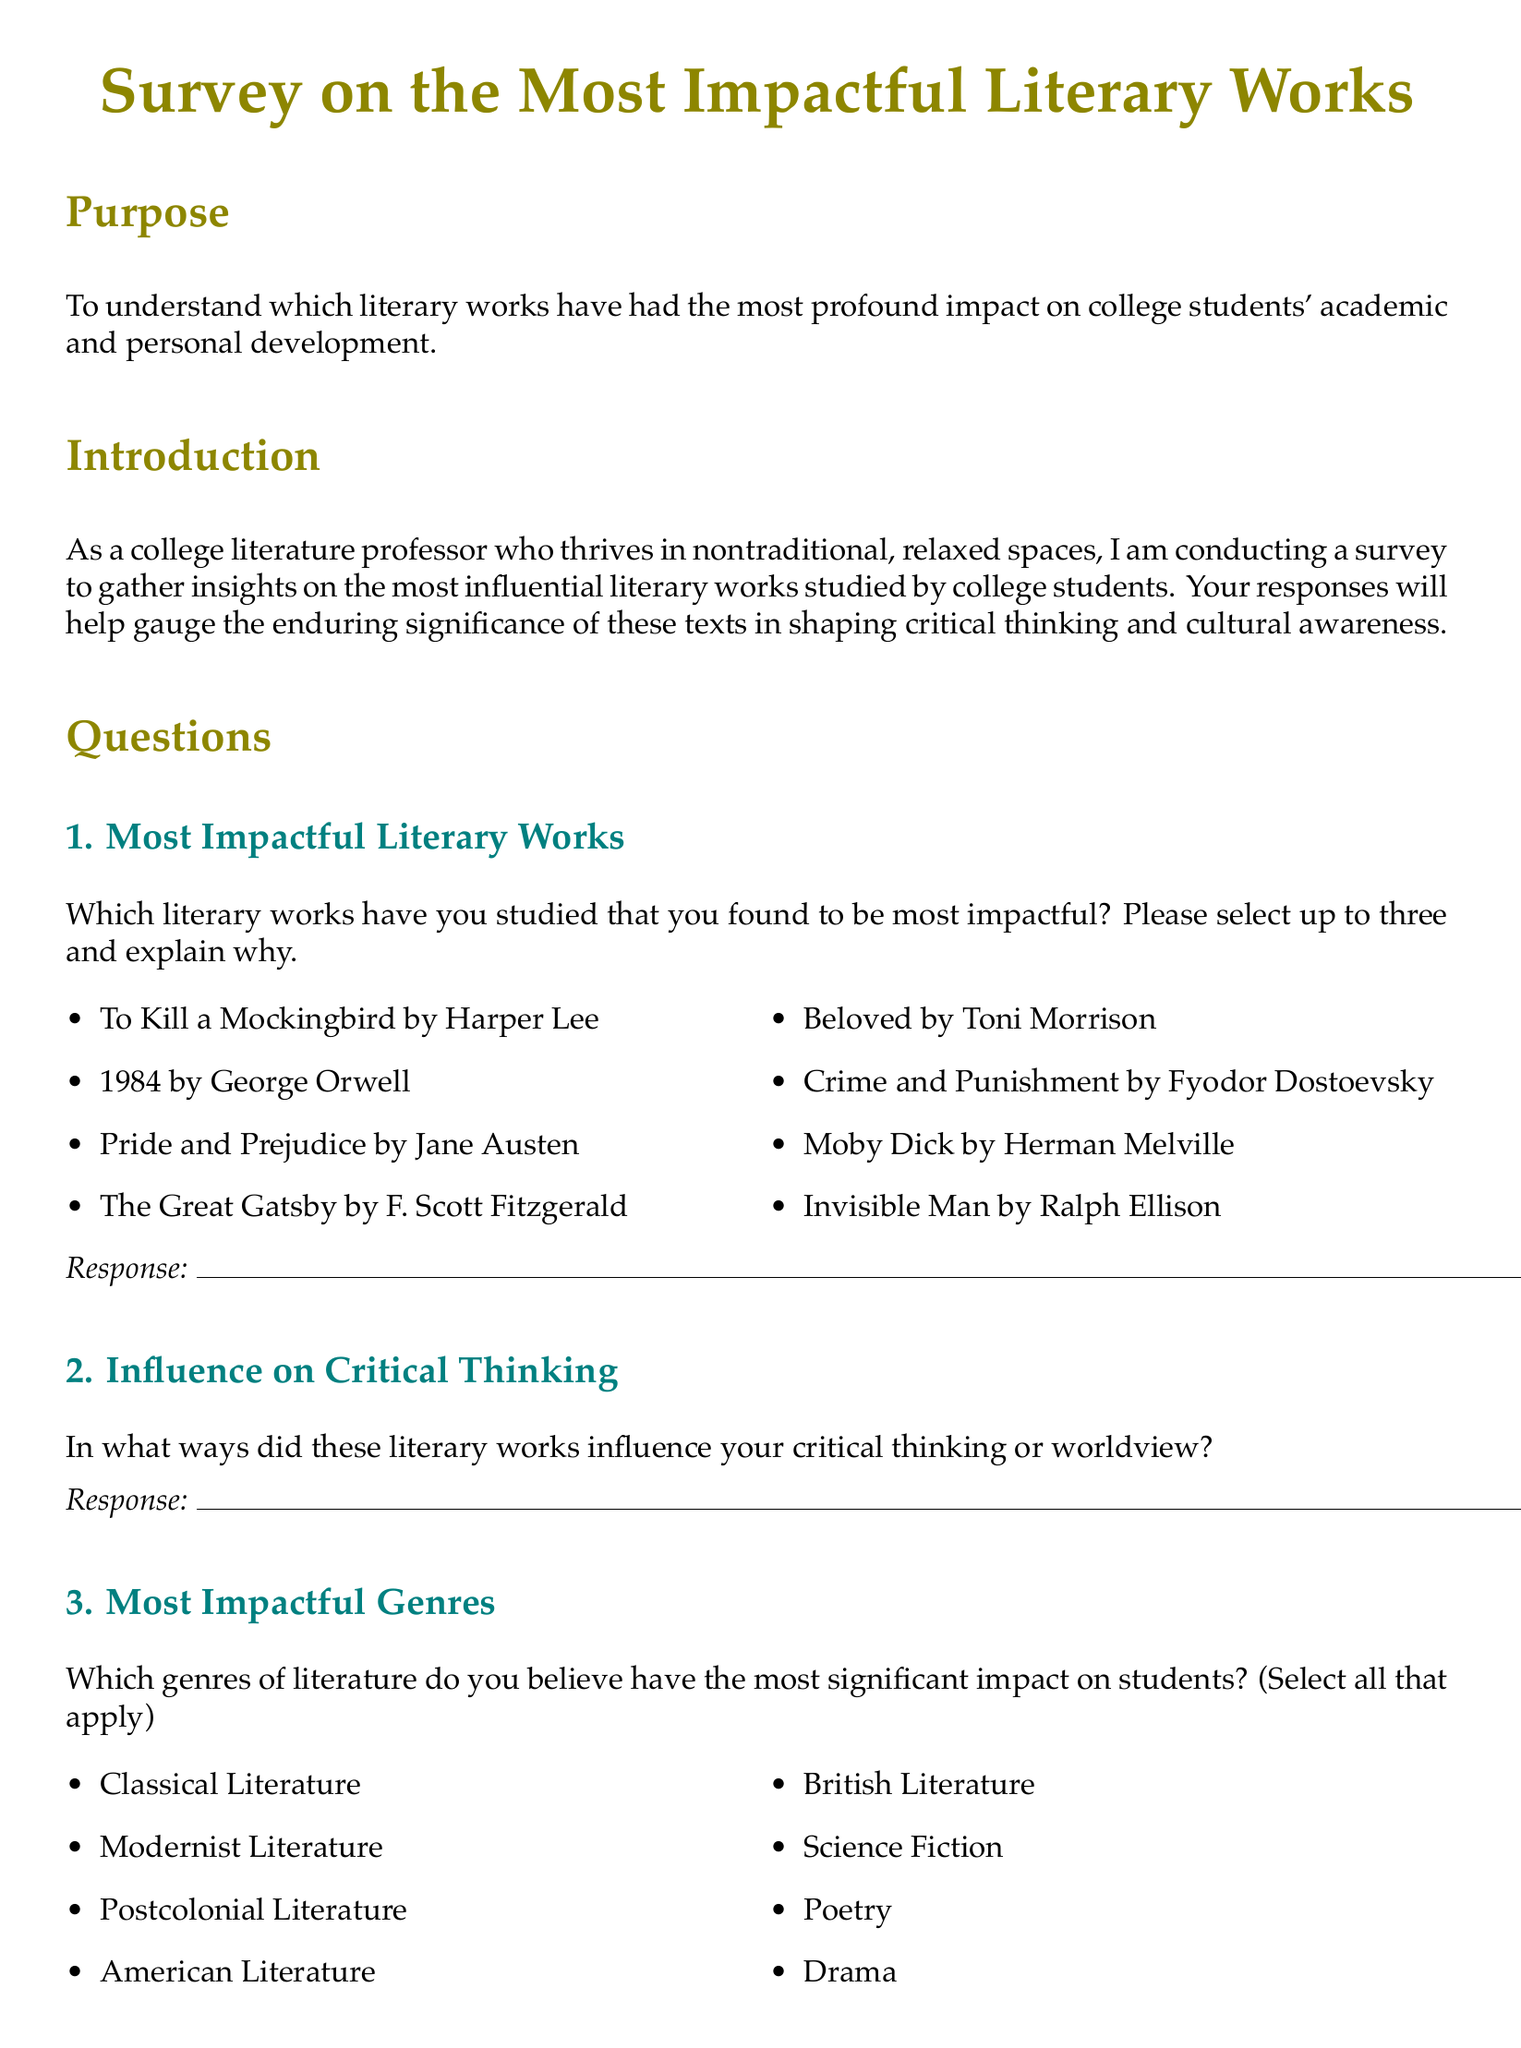What is the title of the survey? The title of the survey is indicated prominently at the beginning of the document.
Answer: Survey on the Most Impactful Literary Works Who is the author of "To Kill a Mockingbird"? The author is mentioned alongside the title under the section listing impactful literary works.
Answer: Harper Lee How many literary works can participants select as impactful? This information specifies the limit on the selection by respondents in the document.
Answer: Up to three What genre is not listed as an option in the survey? By analyzing the provided genres, we can identify which genre is missing from the list.
Answer: Fantasy What is the main purpose of the survey? The document explains the survey's aim at the beginning under the Purpose section.
Answer: To understand which literary works have had the most profound impact on college students' academic and personal development Which section comes right before the "Authors to Include" question? This required understanding the order of the sections in the document.
Answer: Most Impactful Genres Does the document suggest a specific environment for studying literature? The document discusses the influence of studying literature in different environments.
Answer: Nontraditional or relaxed spaces How many specific authors can respondents identify for inclusion in syllabi? This information is provided in the question asking for authors' names.
Answer: Up to three What type of literature is mentioned in both genres and impactful works? This question requires reasoning about the overlap in categories mentioned in the document.
Answer: American Literature 